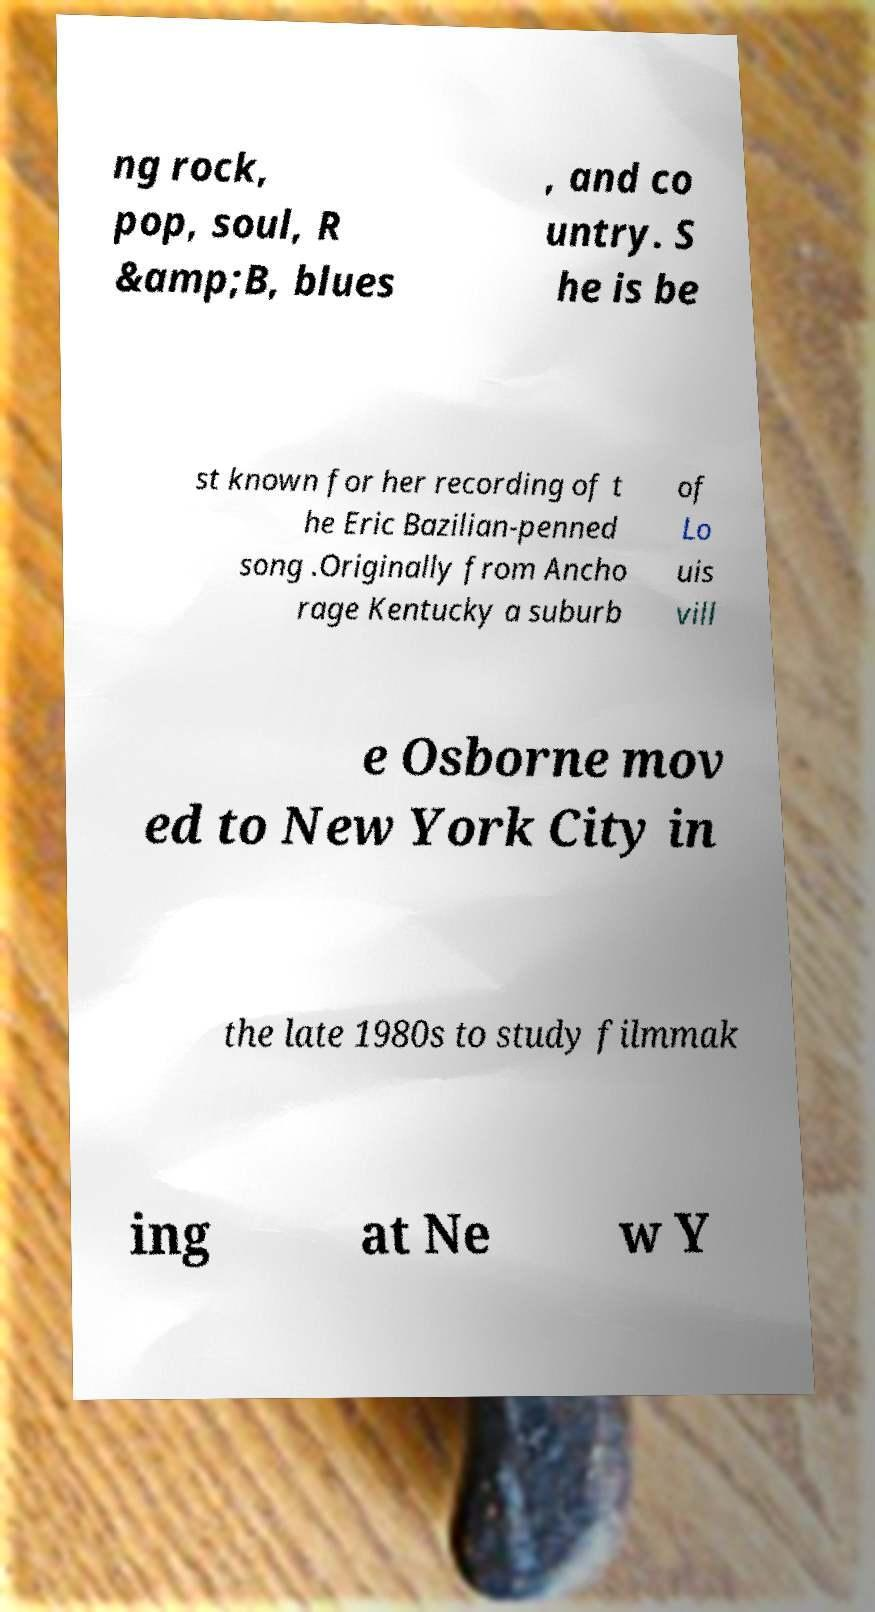Could you extract and type out the text from this image? ng rock, pop, soul, R &amp;B, blues , and co untry. S he is be st known for her recording of t he Eric Bazilian-penned song .Originally from Ancho rage Kentucky a suburb of Lo uis vill e Osborne mov ed to New York City in the late 1980s to study filmmak ing at Ne w Y 